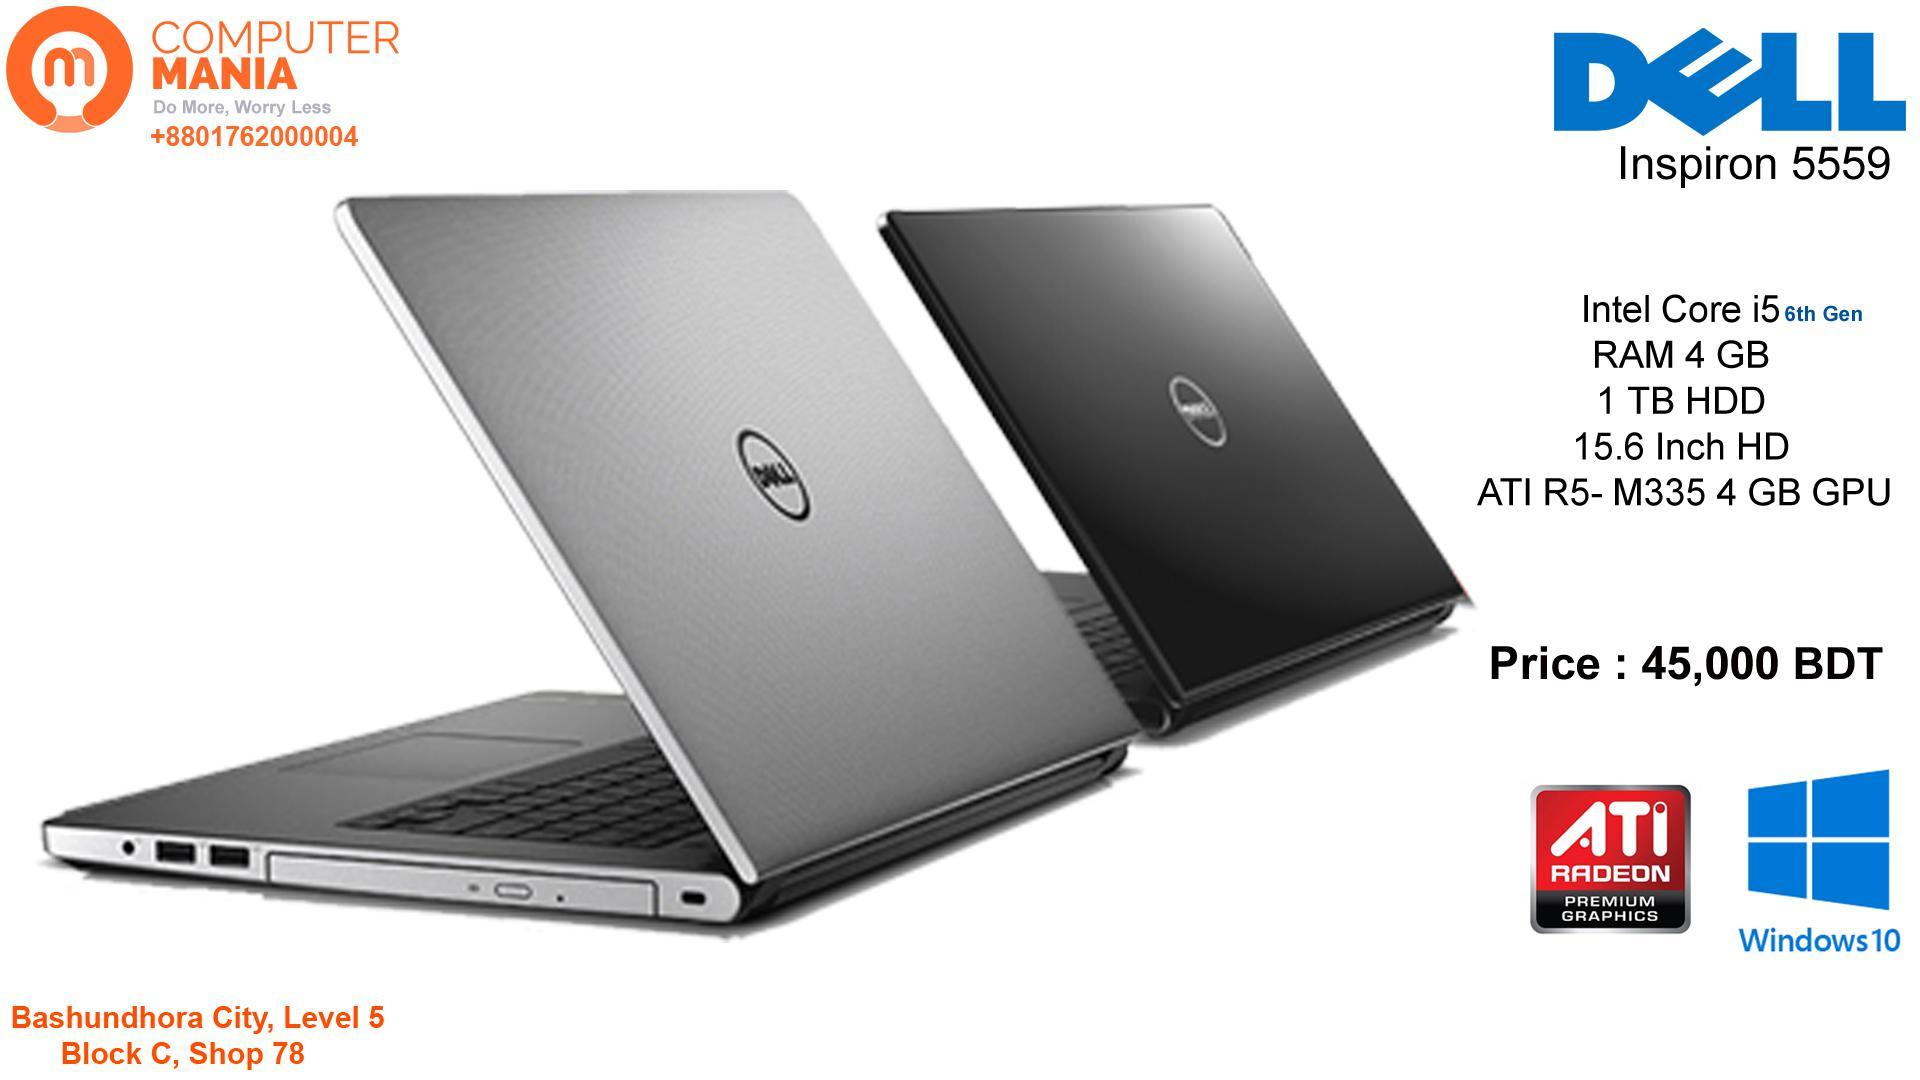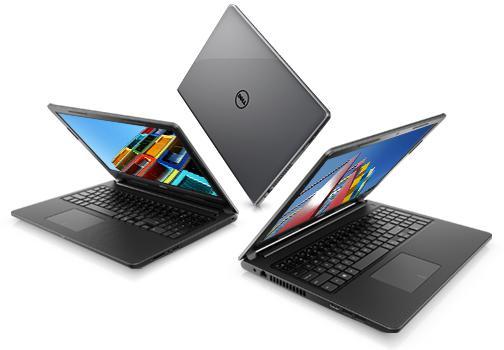The first image is the image on the left, the second image is the image on the right. For the images shown, is this caption "One of the images contains exactly three computers" true? Answer yes or no. Yes. The first image is the image on the left, the second image is the image on the right. Given the left and right images, does the statement "The right and left images contain the same number of laptops." hold true? Answer yes or no. No. 